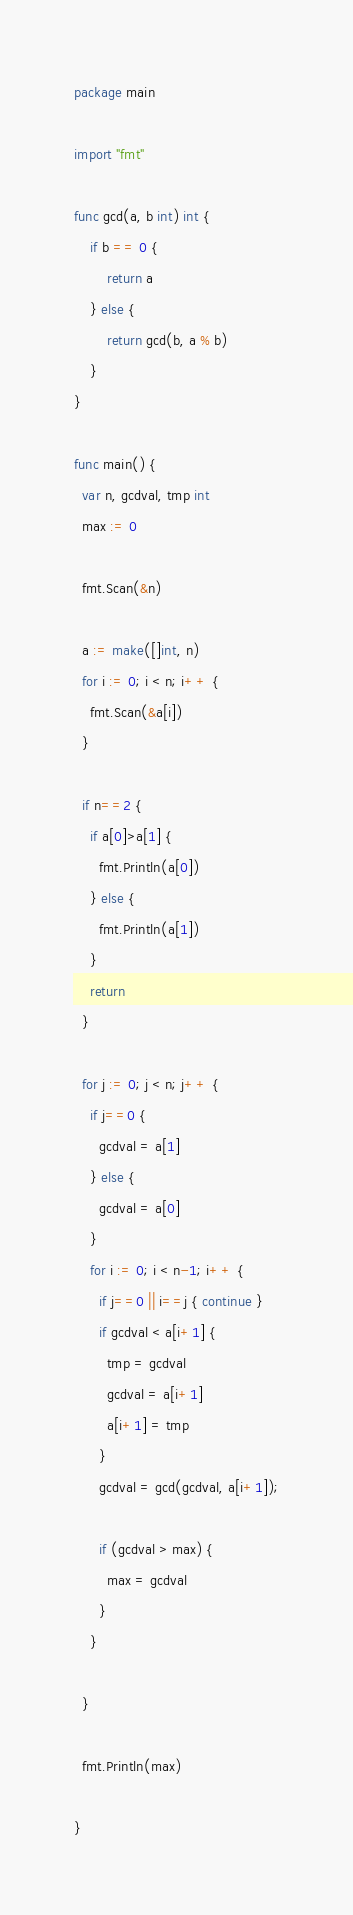<code> <loc_0><loc_0><loc_500><loc_500><_Go_>package main

import "fmt"

func gcd(a, b int) int {
    if b == 0 {
        return a
    } else {
        return gcd(b, a % b)
    }
}

func main() {
  var n, gcdval, tmp int
  max := 0
  
  fmt.Scan(&n)
  
  a := make([]int, n)
  for i := 0; i < n; i++ {
    fmt.Scan(&a[i])
  }
  
  if n==2 {
    if a[0]>a[1] {
      fmt.Println(a[0]) 
    } else {
      fmt.Println(a[1]) 
    }
    return
  }
  
  for j := 0; j < n; j++ {
    if j==0 {
      gcdval = a[1]
    } else {
      gcdval = a[0]
    }
    for i := 0; i < n-1; i++ {
      if j==0 || i==j { continue }
      if gcdval < a[i+1] {
        tmp = gcdval
        gcdval = a[i+1]
        a[i+1] = tmp
      }
      gcdval = gcd(gcdval, a[i+1]);
      
      if (gcdval > max) {
        max = gcdval
      }
    }
    
  }
  
  fmt.Println(max)
  
}

</code> 